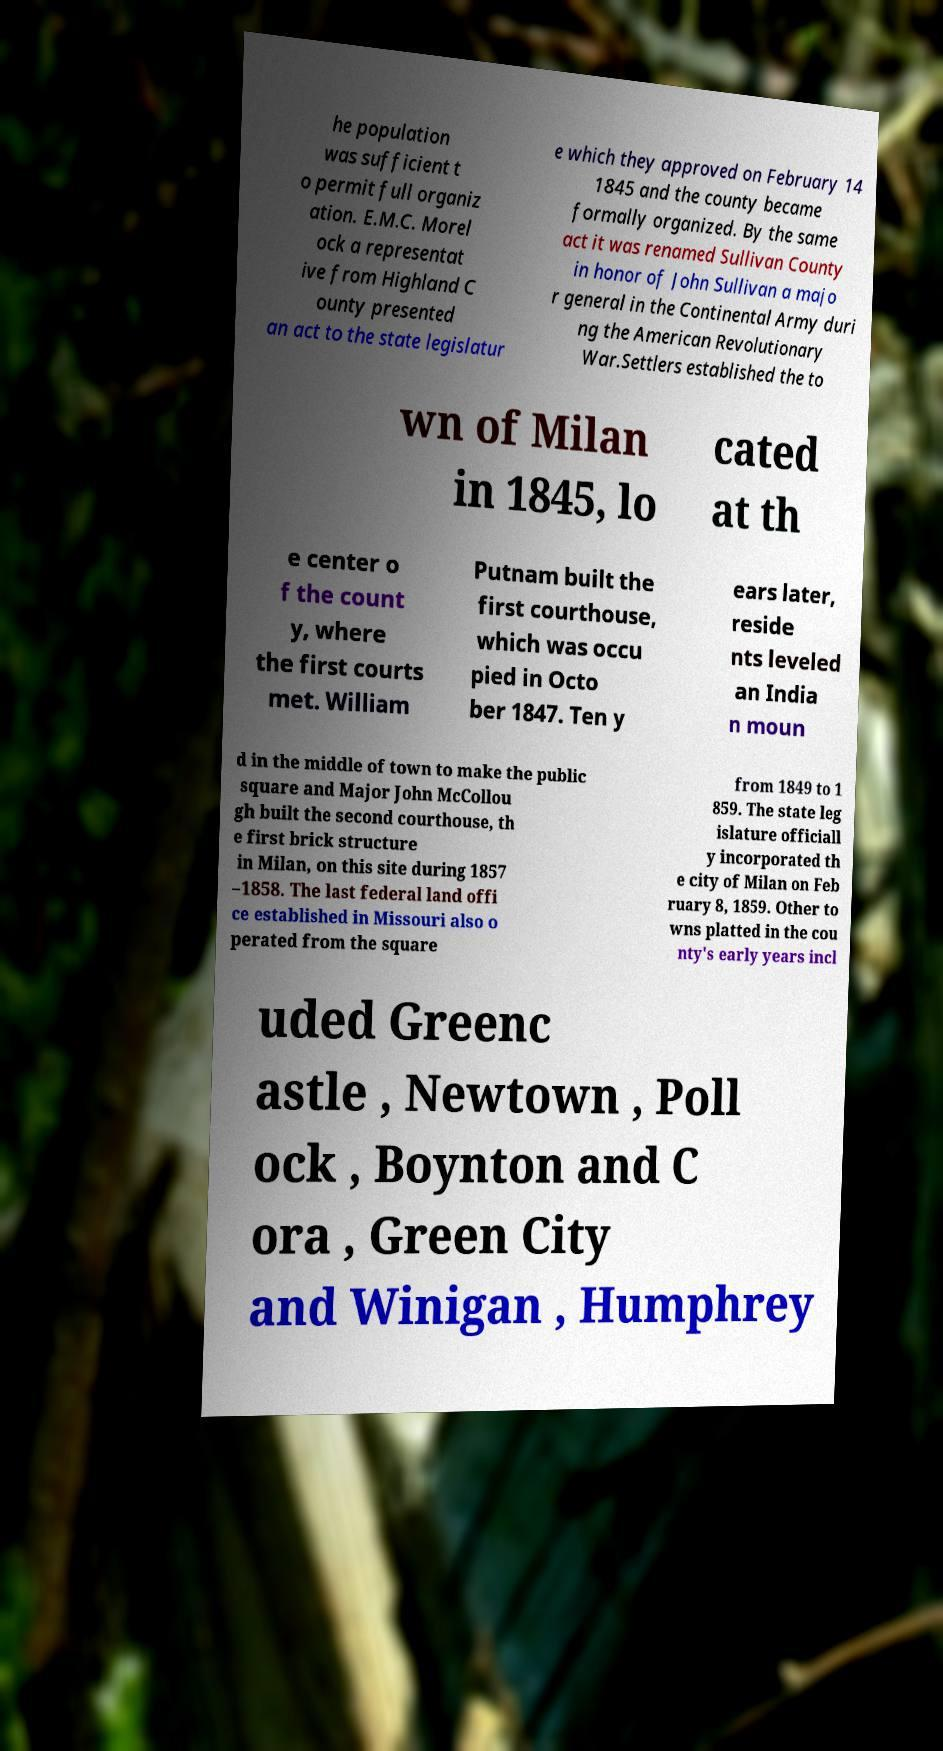I need the written content from this picture converted into text. Can you do that? he population was sufficient t o permit full organiz ation. E.M.C. Morel ock a representat ive from Highland C ounty presented an act to the state legislatur e which they approved on February 14 1845 and the county became formally organized. By the same act it was renamed Sullivan County in honor of John Sullivan a majo r general in the Continental Army duri ng the American Revolutionary War.Settlers established the to wn of Milan in 1845, lo cated at th e center o f the count y, where the first courts met. William Putnam built the first courthouse, which was occu pied in Octo ber 1847. Ten y ears later, reside nts leveled an India n moun d in the middle of town to make the public square and Major John McCollou gh built the second courthouse, th e first brick structure in Milan, on this site during 1857 –1858. The last federal land offi ce established in Missouri also o perated from the square from 1849 to 1 859. The state leg islature officiall y incorporated th e city of Milan on Feb ruary 8, 1859. Other to wns platted in the cou nty's early years incl uded Greenc astle , Newtown , Poll ock , Boynton and C ora , Green City and Winigan , Humphrey 